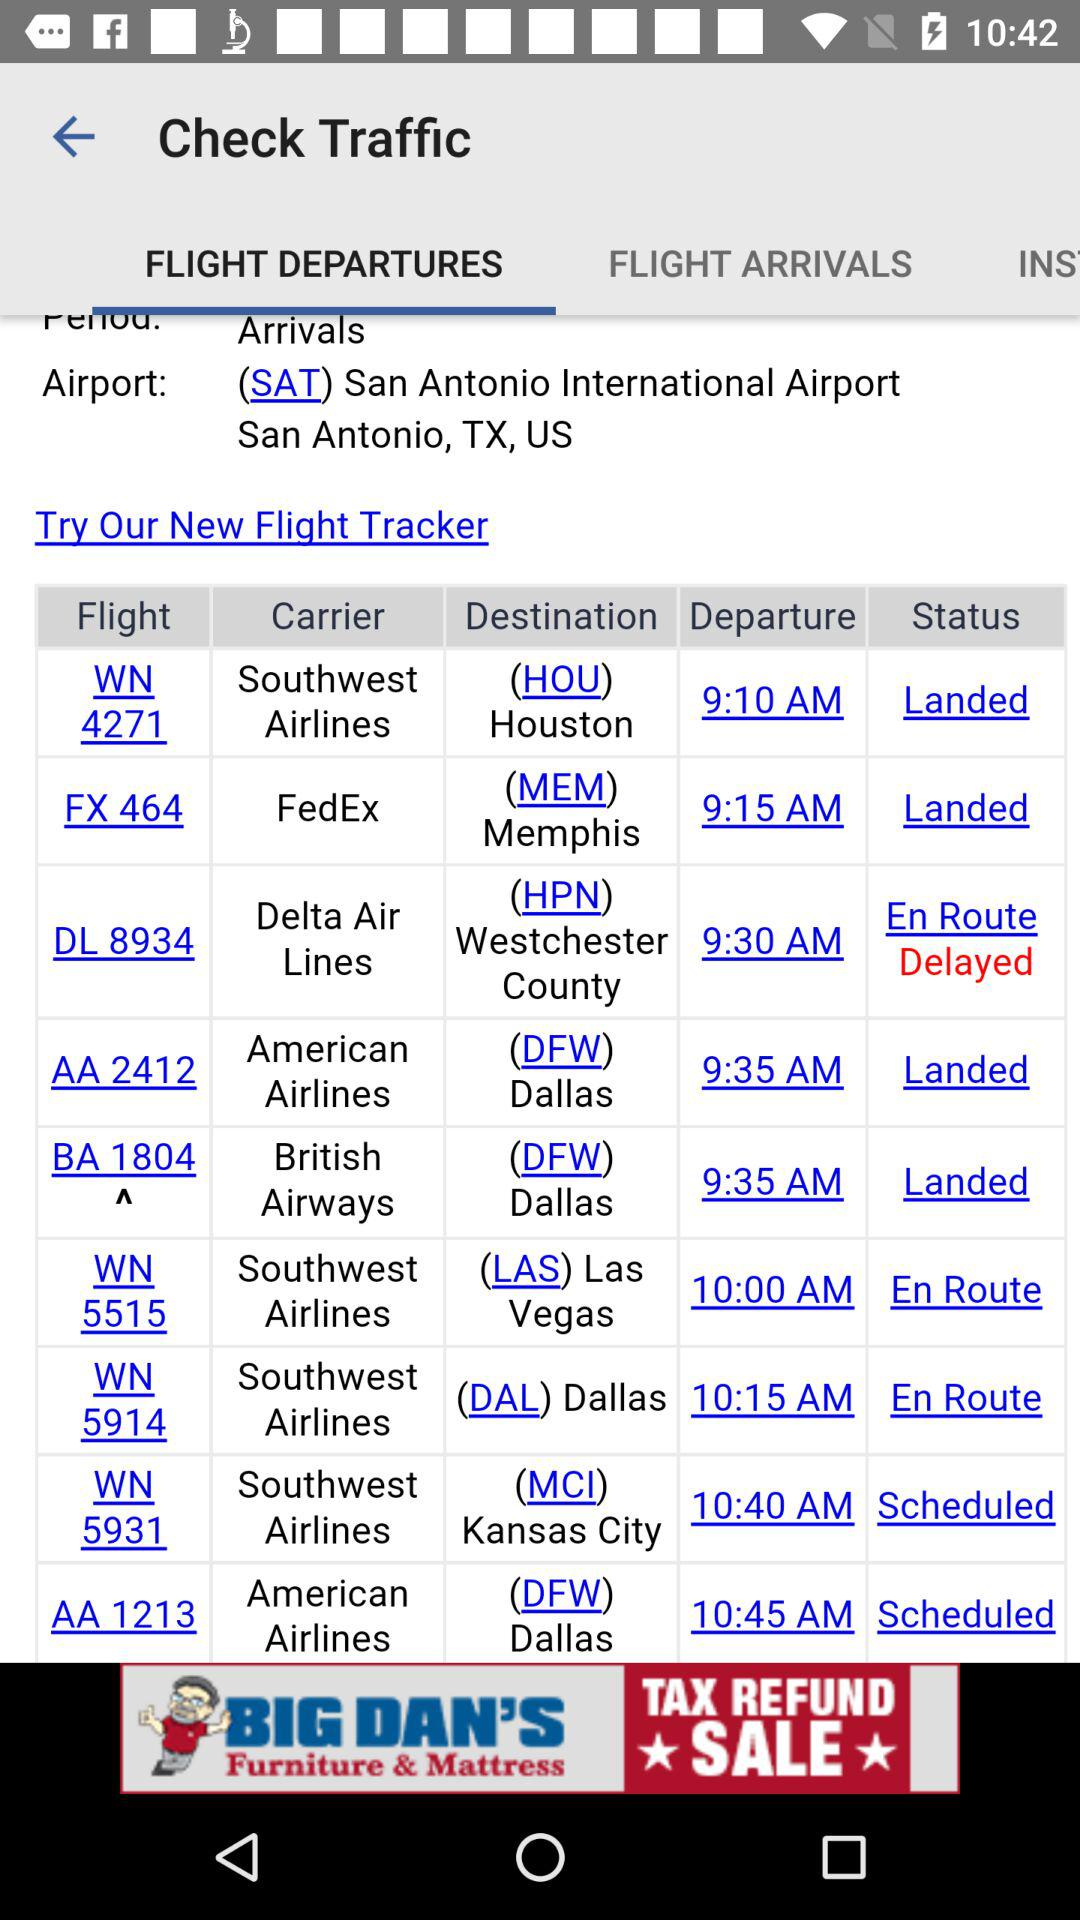What is the number of the flight that is delayed? The number of the flight that is delayed is DL 8934. 